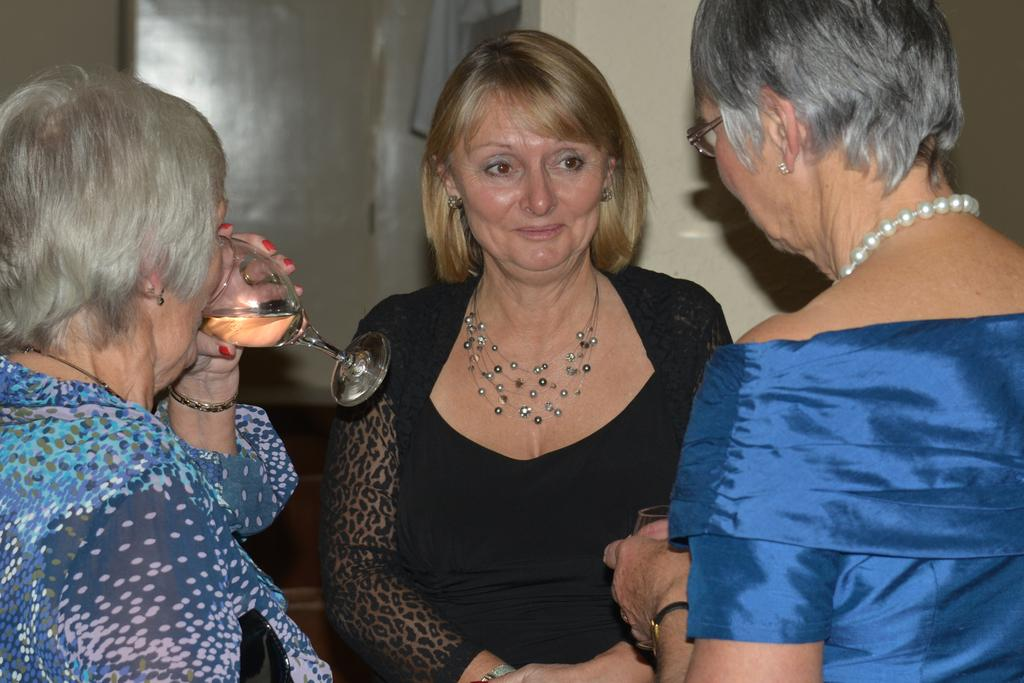How many people are in the image? There are three persons in the image. Can you describe one of the persons in the image? One of the persons is a woman in a black dress. What is the woman holding in the image? The woman is holding a glass. What is the woman doing with the glass? The woman is drinking from the glass. What can be seen in the background of the image? There is a wall in the background of the image. What type of receipt can be seen in the woman's hand in the image? There is no receipt visible in the woman's hand in the image; she is holding a glass. Who is the woman's aunt in the image? The image does not provide information about the woman's family members, so it cannot be determined who her aunt is. 